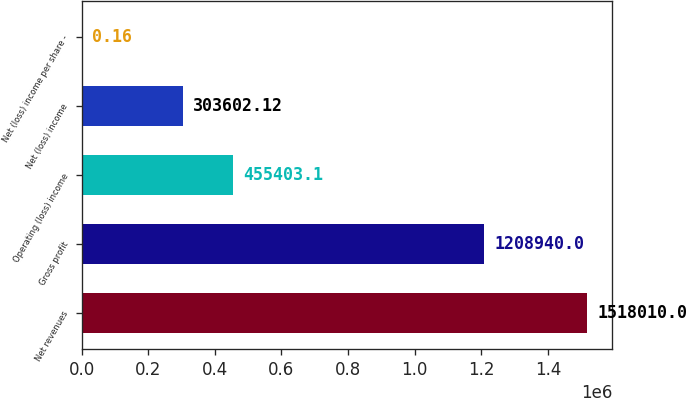Convert chart to OTSL. <chart><loc_0><loc_0><loc_500><loc_500><bar_chart><fcel>Net revenues<fcel>Gross profit<fcel>Operating (loss) income<fcel>Net (loss) income<fcel>Net (loss) income per share -<nl><fcel>1.51801e+06<fcel>1.20894e+06<fcel>455403<fcel>303602<fcel>0.16<nl></chart> 